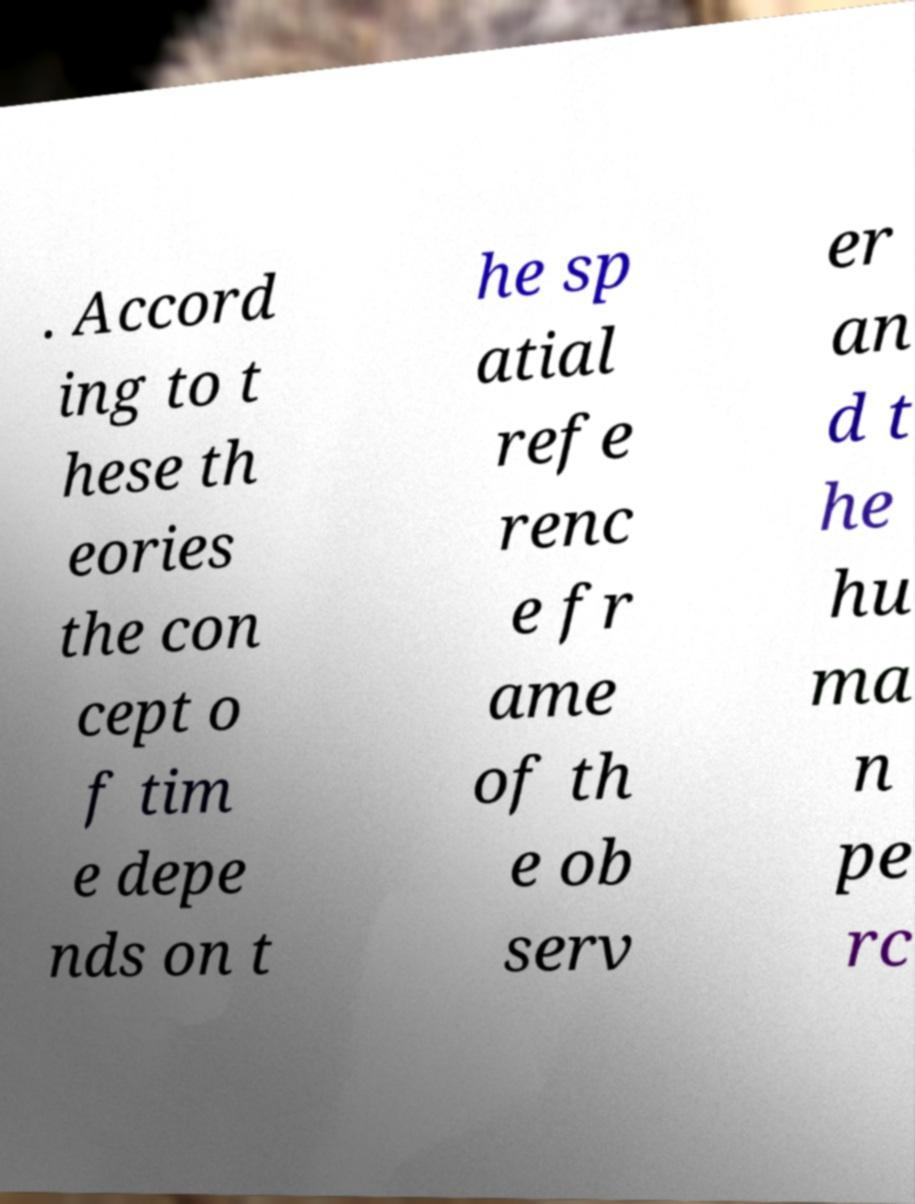Can you accurately transcribe the text from the provided image for me? . Accord ing to t hese th eories the con cept o f tim e depe nds on t he sp atial refe renc e fr ame of th e ob serv er an d t he hu ma n pe rc 